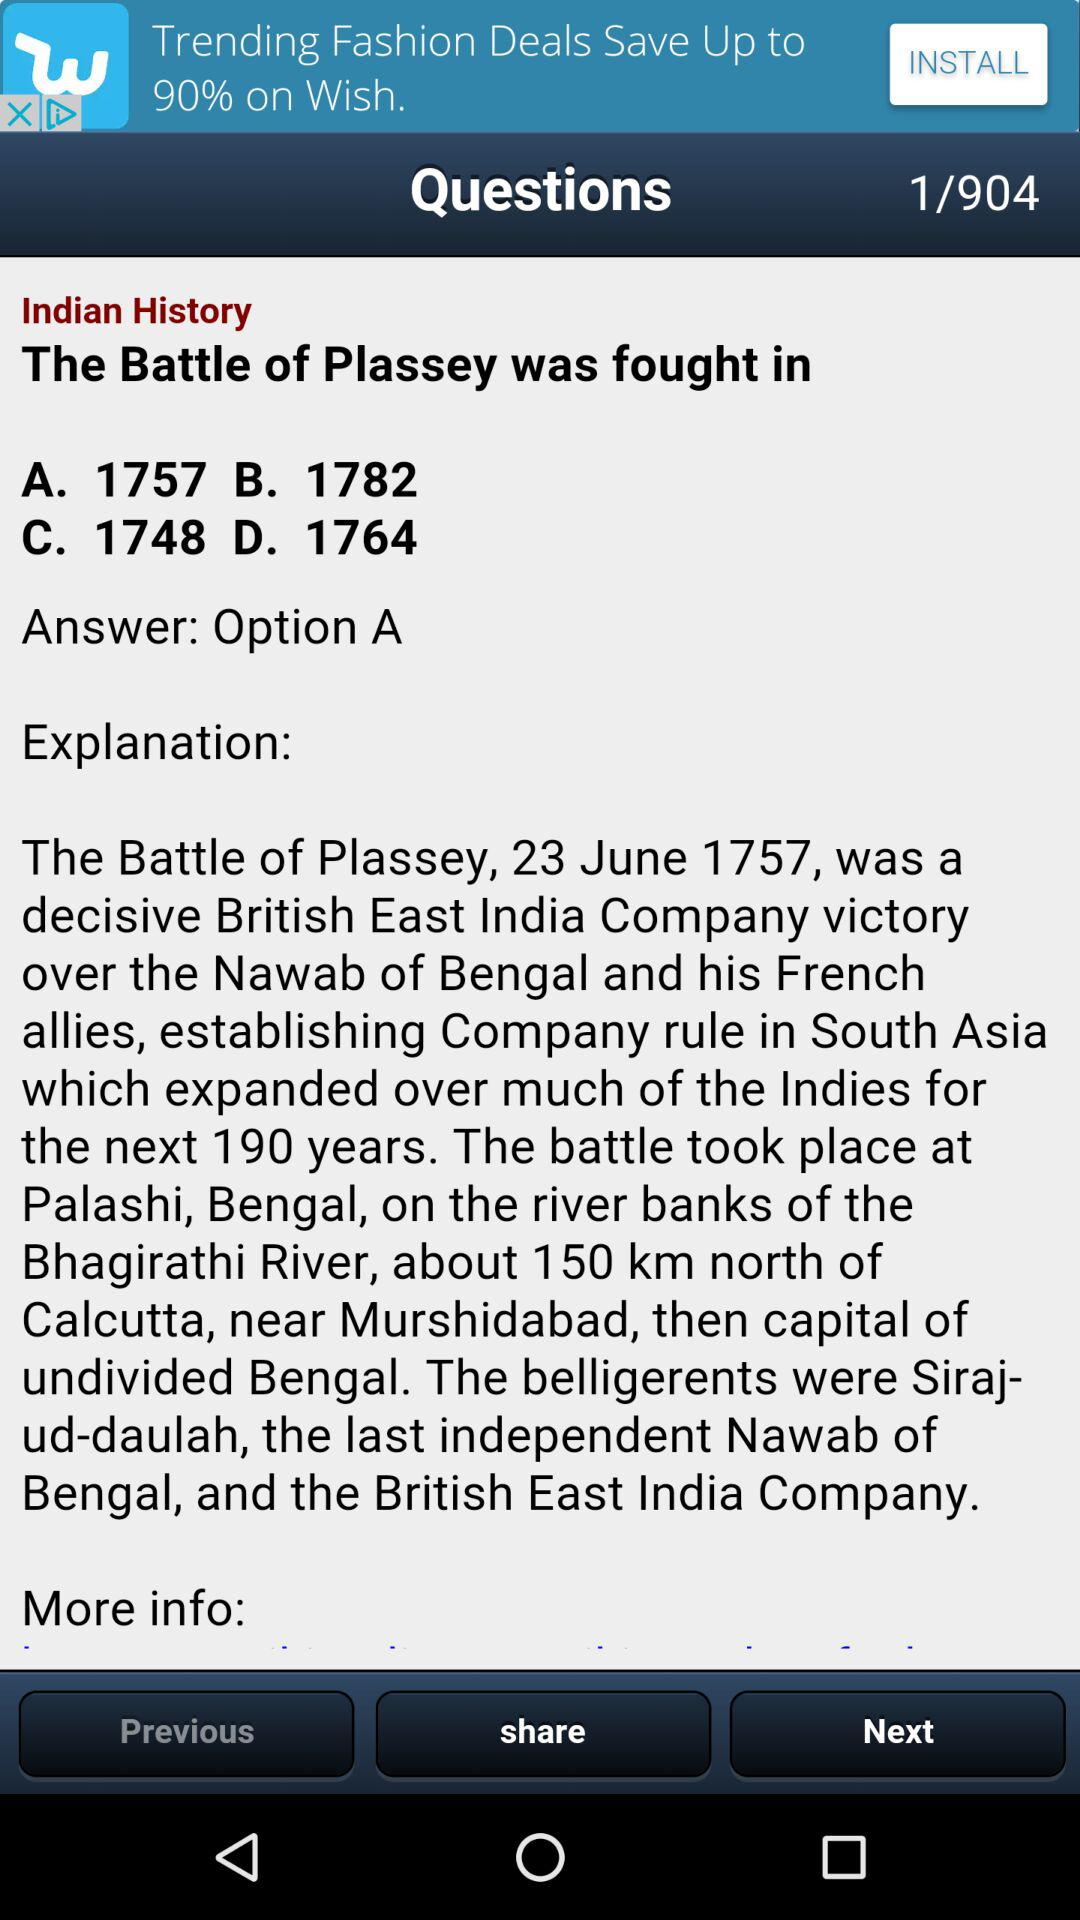How many years before 1782 was the Battle of Plassey fought?
Answer the question using a single word or phrase. 25 